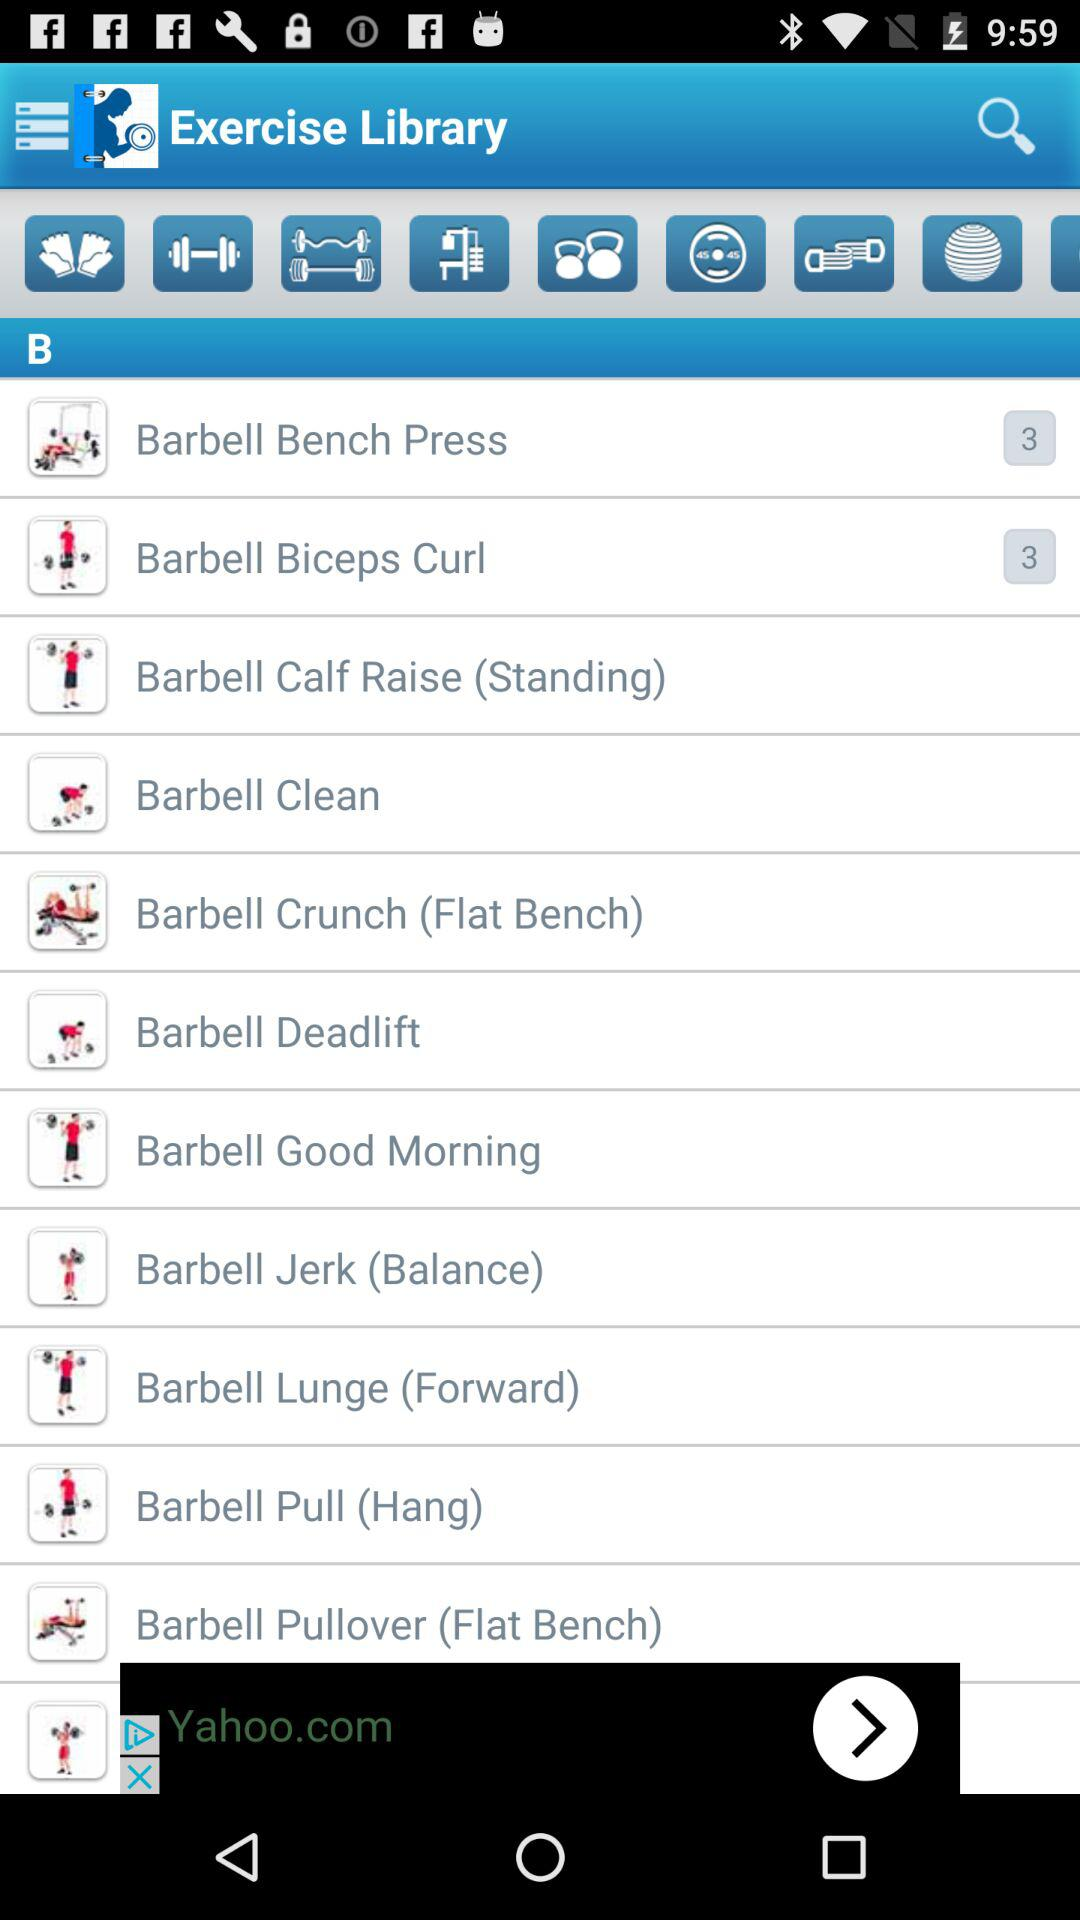What is the name of the application? The name of the application is "Fitness Buddy: Gym Workout, We". 